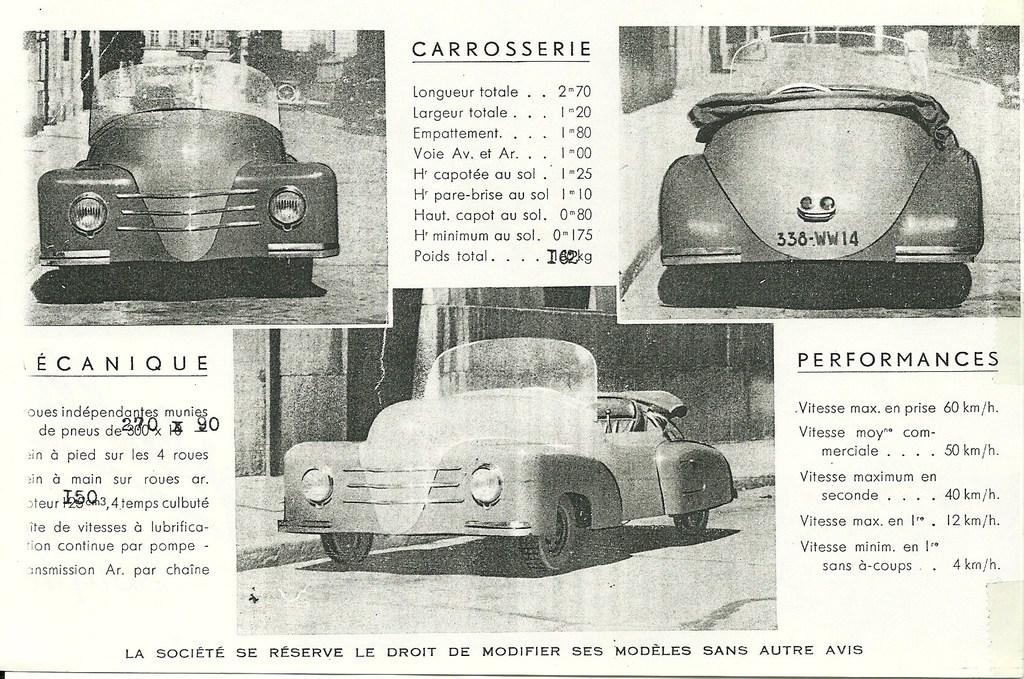What is the main object in the image? There is a paper in the image. What else can be seen in the image besides the paper? There are three cars in the image. Is there any text visible in the image? Yes, there is some text visible in the image. What type of meal is being prepared in the image? There is no meal being prepared in the image; it features a paper and three cars. 